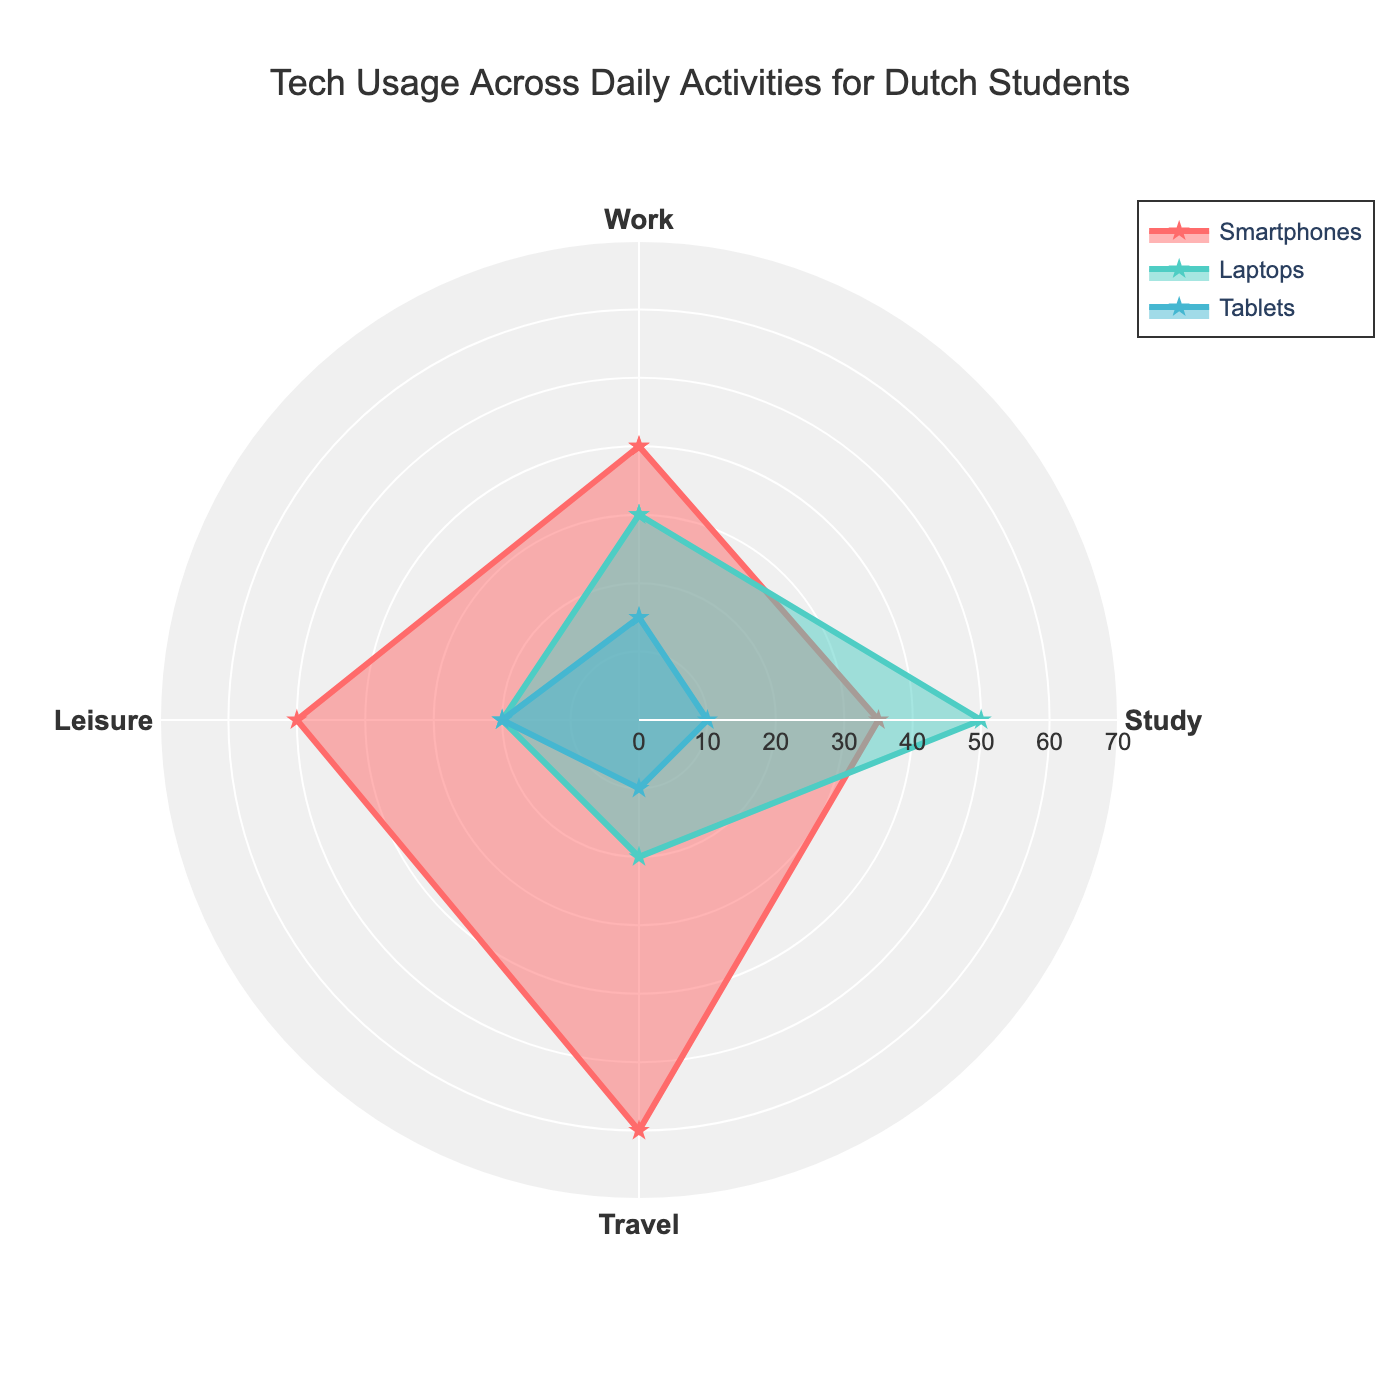What are the four categories shown in the radar chart? The radar chart displays data for different categories. These categories are noted on the central axes of the chart.
Answer: Work, Study, Travel, Leisure Which device has the highest usage in the "Travel" category? By looking at the values for the "Travel" category, the device with the highest value is easily identifiable by the length of the radar chart's axis.
Answer: Smartphones Which activity shows the least variance in device usage? Variance in device usage can be visually assessed by comparing the spread of values for each category across the different devices. The category with the closest values among devices has the least variance.
Answer: Study What is the total usage of devices for the "Leisure" category? To find the total usage, sum the values of all devices for the "Leisure" category: smartphones (50) + laptops (20) + tablets (20) + smartwatches (10).
Answer: 100 Which device has the most balanced usage across the four activities? A device with balanced usage would have values that are more consistent and don't vary dramatically across the activities.
Answer: Smartwatches In the "Work" category, how much more are smartphones used compared to tablets? To find the difference in usage between smartphones and tablets in the "Work" category, subtract the usage of tablets (15) from smartphones (40).
Answer: 25 If you average the usage of laptops across all categories, what's the value? Add up the laptop usage in all categories and divide by the number of categories: (30 for Work + 50 for Study + 20 for Travel + 20 for Leisure) / 4.
Answer: 30 Are tablets used more for "Study" or "Leisure"? By comparing the usage values of tablets in the "Study" and "Leisure" categories, you can identify which one is higher.
Answer: Leisure What is the range of smartwatch usage across all categories? The range is the difference between the maximum and minimum values of smartwatch usage: max (15 in Work) - min (5 in Study).
Answer: 10 